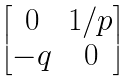Convert formula to latex. <formula><loc_0><loc_0><loc_500><loc_500>\begin{bmatrix} 0 & 1 / p \\ - q & 0 \end{bmatrix}</formula> 